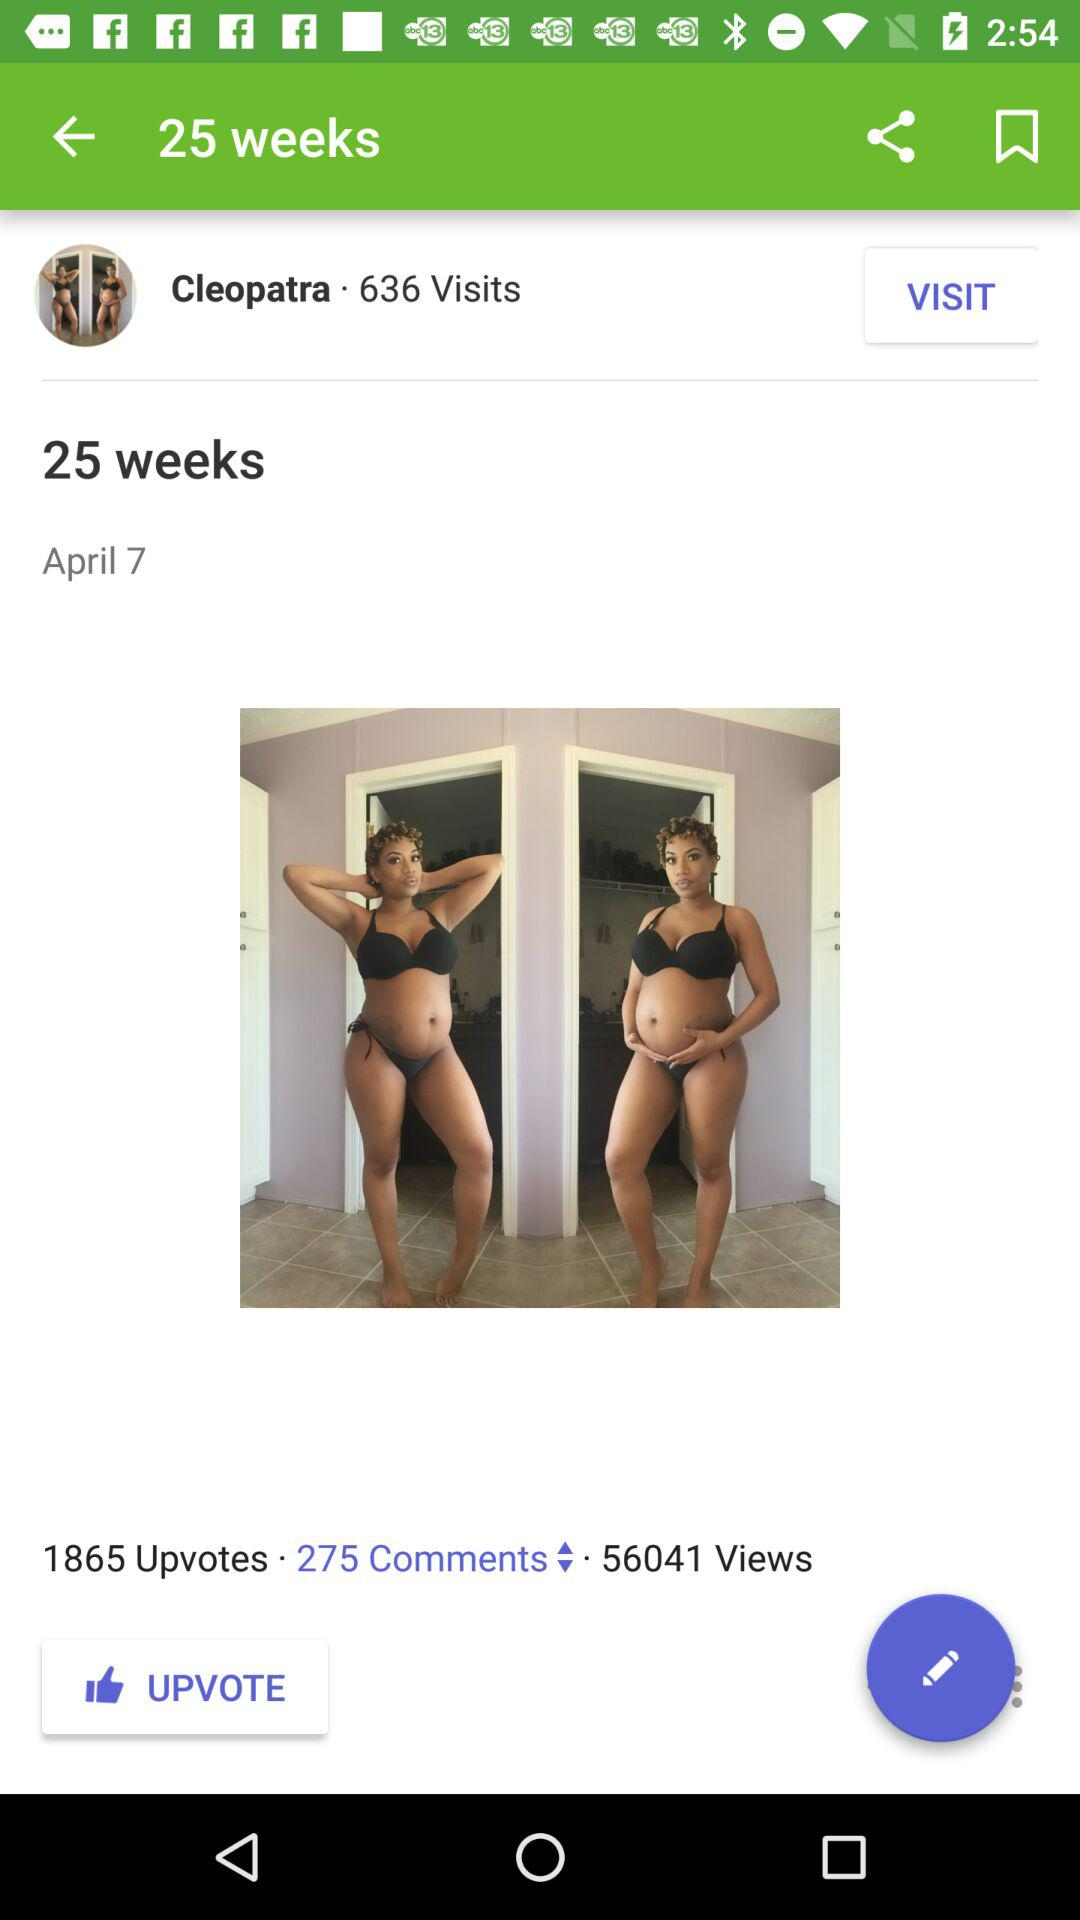What is the comment count? The comment count is 275. 